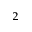<formula> <loc_0><loc_0><loc_500><loc_500>^ { 2 }</formula> 